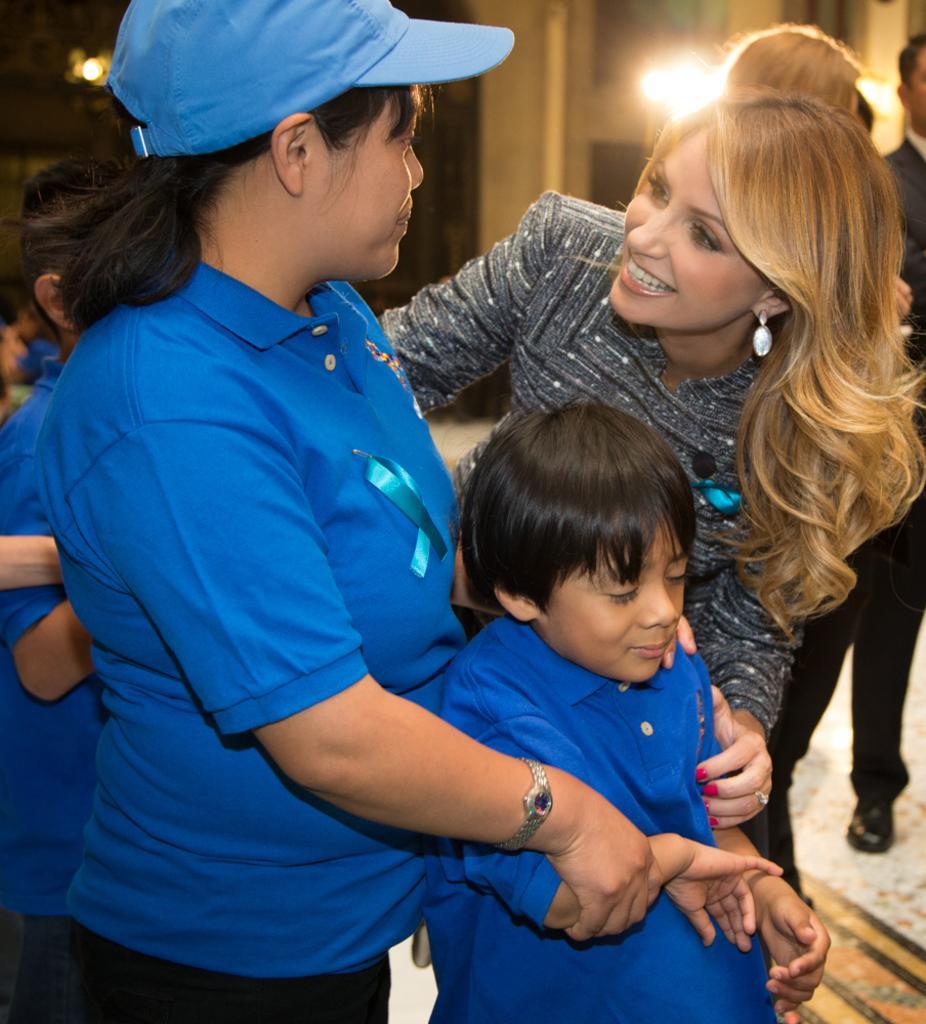Could you give a brief overview of what you see in this image? In this image in the foreground there are some people who are standing and in the background there is a wall and some lights. At the bottom there is a floor. 